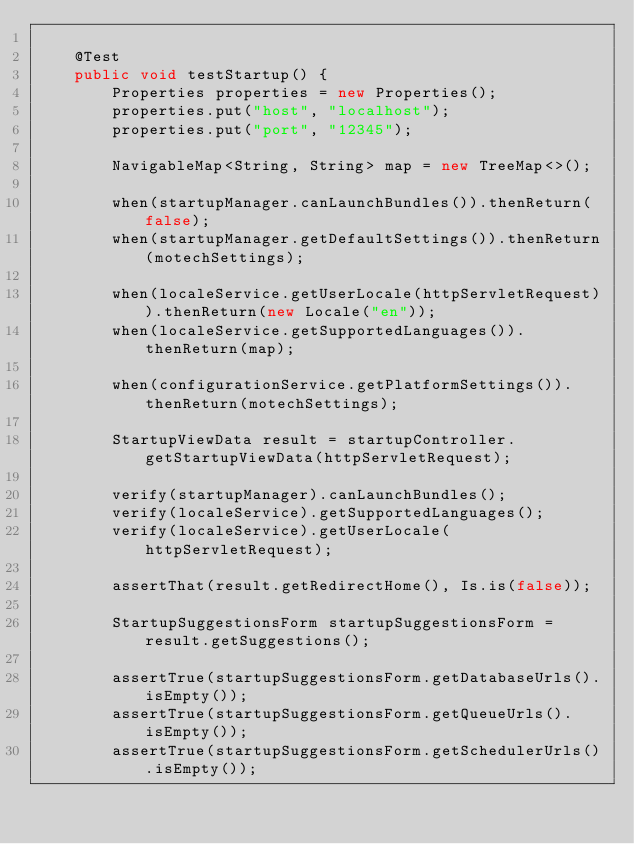Convert code to text. <code><loc_0><loc_0><loc_500><loc_500><_Java_>
    @Test
    public void testStartup() {
        Properties properties = new Properties();
        properties.put("host", "localhost");
        properties.put("port", "12345");

        NavigableMap<String, String> map = new TreeMap<>();

        when(startupManager.canLaunchBundles()).thenReturn(false);
        when(startupManager.getDefaultSettings()).thenReturn(motechSettings);

        when(localeService.getUserLocale(httpServletRequest)).thenReturn(new Locale("en"));
        when(localeService.getSupportedLanguages()).thenReturn(map);

        when(configurationService.getPlatformSettings()).thenReturn(motechSettings);

        StartupViewData result = startupController.getStartupViewData(httpServletRequest);

        verify(startupManager).canLaunchBundles();
        verify(localeService).getSupportedLanguages();
        verify(localeService).getUserLocale(httpServletRequest);

        assertThat(result.getRedirectHome(), Is.is(false));

        StartupSuggestionsForm startupSuggestionsForm = result.getSuggestions();

        assertTrue(startupSuggestionsForm.getDatabaseUrls().isEmpty());
        assertTrue(startupSuggestionsForm.getQueueUrls().isEmpty());
        assertTrue(startupSuggestionsForm.getSchedulerUrls().isEmpty());
</code> 